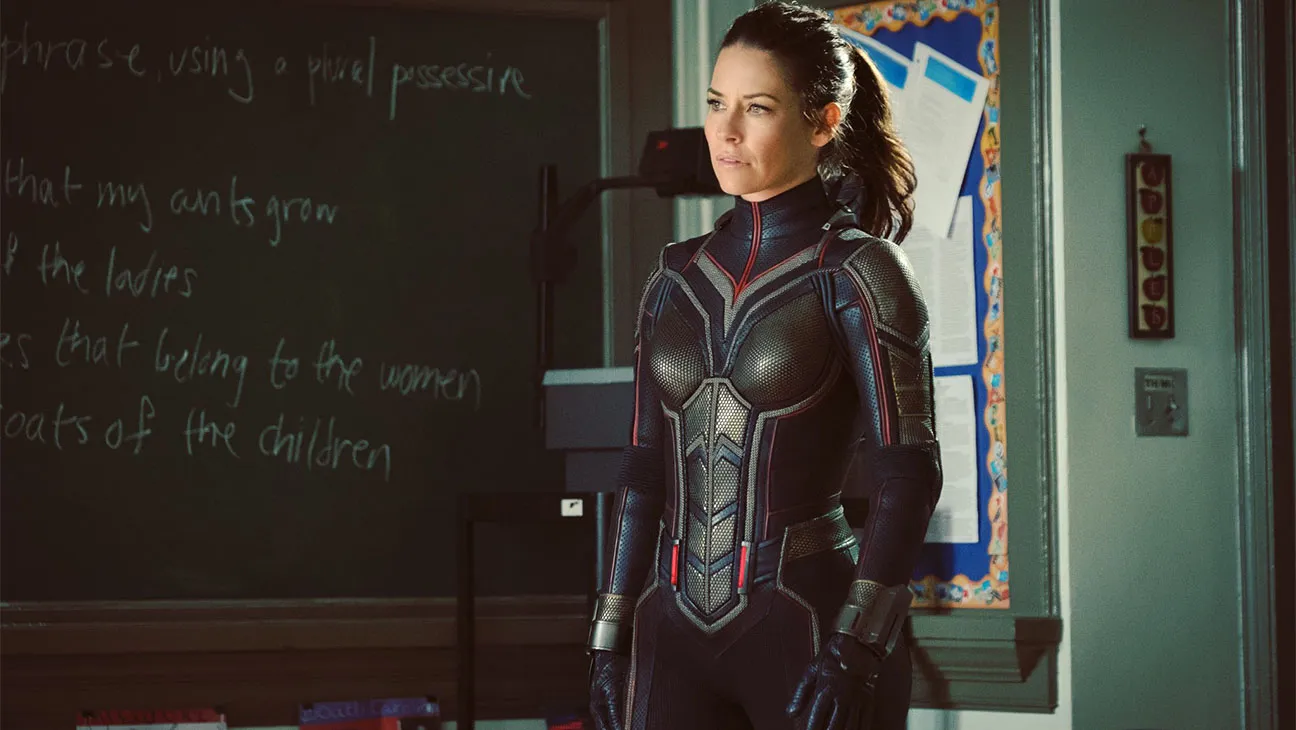How do you think the character's suit aids her in her role? The suit is likely designed to enhance her physical abilities, provide protection, and possibly offer advanced technology for various tasks. The sleek design and form-fitting nature suggest it supports agility and combat readiness, while the materials seem durable, offering protection against physical impacts. Can you imagine a plot where she needs to use her suit in the classroom setting? Imagine a scenario where the character needs to protect a group of students from an unexpected threat. Her suit's advanced technology allows her to detect danger, create protective barriers, and even communicate with the students to guide them to safety. In this intense and dramatic scenario, the classroom becomes a temporary battleground where she utilizes every feature of her suit to ensure everyone's safety while dealing with the threat. If this was a scene in a movie, what do you think happened right before and right after this moment? Right before this moment, the character might have been briefing a group of students or other characters about an impending threat, explaining the gravity of the situation. Her serious expression suggests that she has just received critical information or made a crucial decision. Right after this moment, she could spring into action, utilizing her suit's capabilities to confront the threat head-on, coordinate a plan with others, or execute a rapid evacuation of the area. Imagine if the classroom blackboard had a secret code written on it. What could it lead to? If the blackboard concealed a secret code, it could lead to a hidden laboratory or a secured vault containing advanced technology or crucial information. Deciphering the code might reveal coordinates or a password that unlocks a hidden section of the classroom, transforming ordinary surroundings into a high-tech command center or leading to an underground passageway. This twist could add an element of mystery and adventure to the scene, emphasizing the secretive and high-stakes nature of the character's mission. 